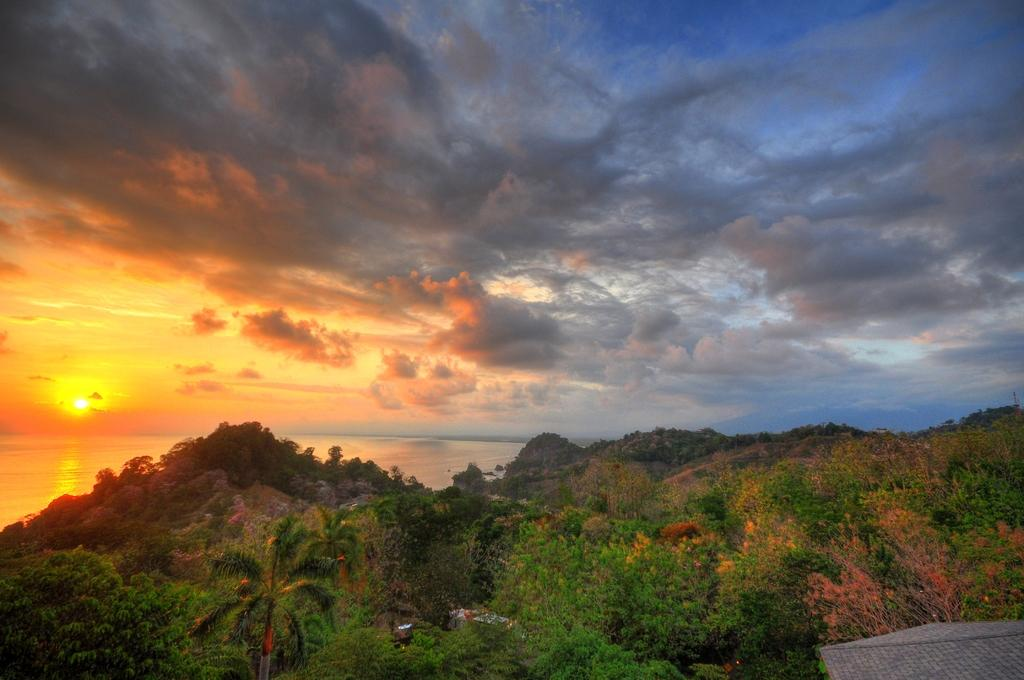What type of vegetation can be seen in the image? There are green trees in the image. What natural feature is present in the image? There is a sea in the image. How would you describe the sky in the image? The sky in the image has a sunset appearance. What else can be seen in the sky besides the sunset? Clouds are visible in the sky. How many pets are visible in the image? There are no pets present in the image. What type of clocks can be seen in the image? There are no clocks present in the image. 